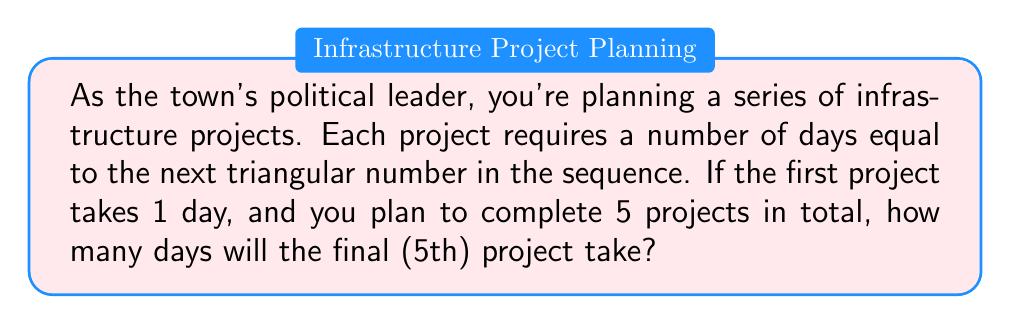Can you solve this math problem? Let's approach this step-by-step:

1) First, recall that triangular numbers are a sequence where each number is the sum of the integers from 1 to n. The formula for the nth triangular number is:

   $$T_n = \frac{n(n+1)}{2}$$

2) We're told that the projects follow this sequence, starting with 1 day for the first project. Let's list out the triangular numbers for the first 5 projects:

   Project 1: $T_1 = \frac{1(1+1)}{2} = 1$ day
   Project 2: $T_2 = \frac{2(2+1)}{2} = 3$ days
   Project 3: $T_3 = \frac{3(3+1)}{2} = 6$ days
   Project 4: $T_4 = \frac{4(4+1)}{2} = 10$ days
   Project 5: $T_5 = \frac{5(5+1)}{2} = 15$ days

3) The question asks for the duration of the 5th project, which we've calculated to be 15 days.

This sequence provides a reasonable model for increasing project complexity, which could be useful for estimating timelines in town planning.
Answer: 15 days 